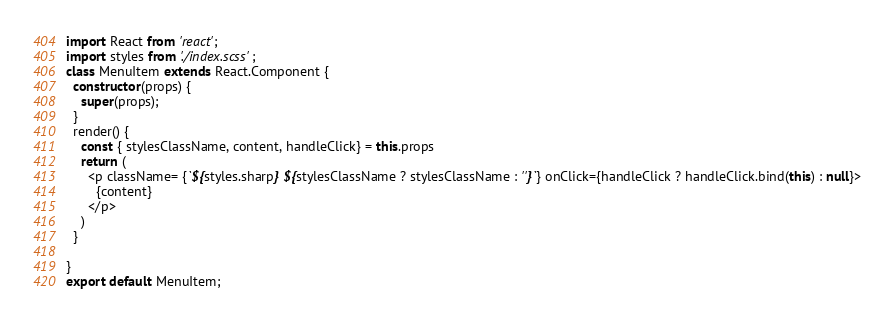Convert code to text. <code><loc_0><loc_0><loc_500><loc_500><_TypeScript_>import React from 'react';
import styles from './index.scss';
class MenuItem extends React.Component {
  constructor(props) {
    super(props);
  }
  render() {
    const { stylesClassName, content, handleClick} = this.props
    return (
      <p className= {`${styles.sharp} ${stylesClassName ? stylesClassName : ''}`} onClick={handleClick ? handleClick.bind(this) : null}>
        {content}
      </p>
    )
  }

}
export default MenuItem;
</code> 